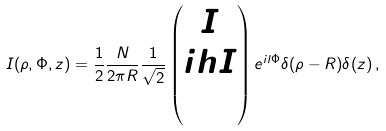Convert formula to latex. <formula><loc_0><loc_0><loc_500><loc_500>I ( \rho , \Phi , z ) = \frac { 1 } { 2 } \frac { N } { 2 \pi R } \frac { 1 } { \sqrt { 2 } } \begin{pmatrix} I \\ i h I \\ 0 \end{pmatrix} e ^ { i l \Phi } \delta ( \rho - R ) \delta ( z ) \, ,</formula> 